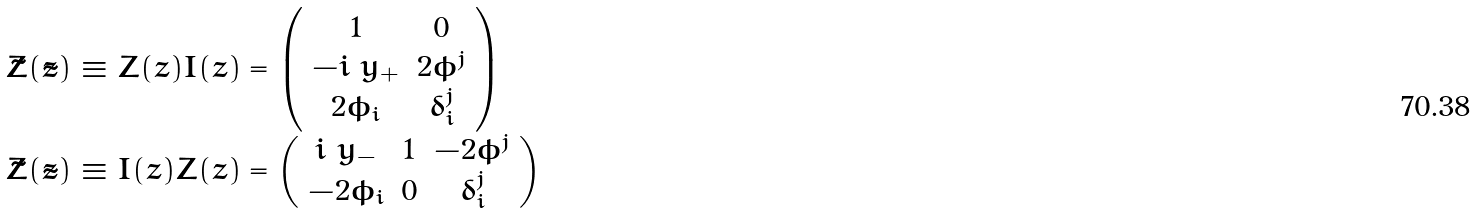<formula> <loc_0><loc_0><loc_500><loc_500>\begin{array} { l } \tilde { Z } ( \tilde { z } ) \equiv Z ( z ) I ( z ) = \left ( \begin{array} { c c } 1 & 0 \\ - i \ y _ { + } & 2 \phi ^ { j } \\ 2 \bar { \phi } _ { i } & \delta _ { i } ^ { j } \end{array} \right ) \\ \bar { \tilde { Z } } ( \tilde { z } ) \equiv \bar { I } ( z ) \bar { Z } ( z ) = \left ( \begin{array} { c c c } i \ y _ { - } & 1 & - 2 \phi ^ { j } \\ - 2 \bar { \phi } _ { i } & 0 & \delta _ { i } ^ { j } \end{array} \right ) \end{array}</formula> 